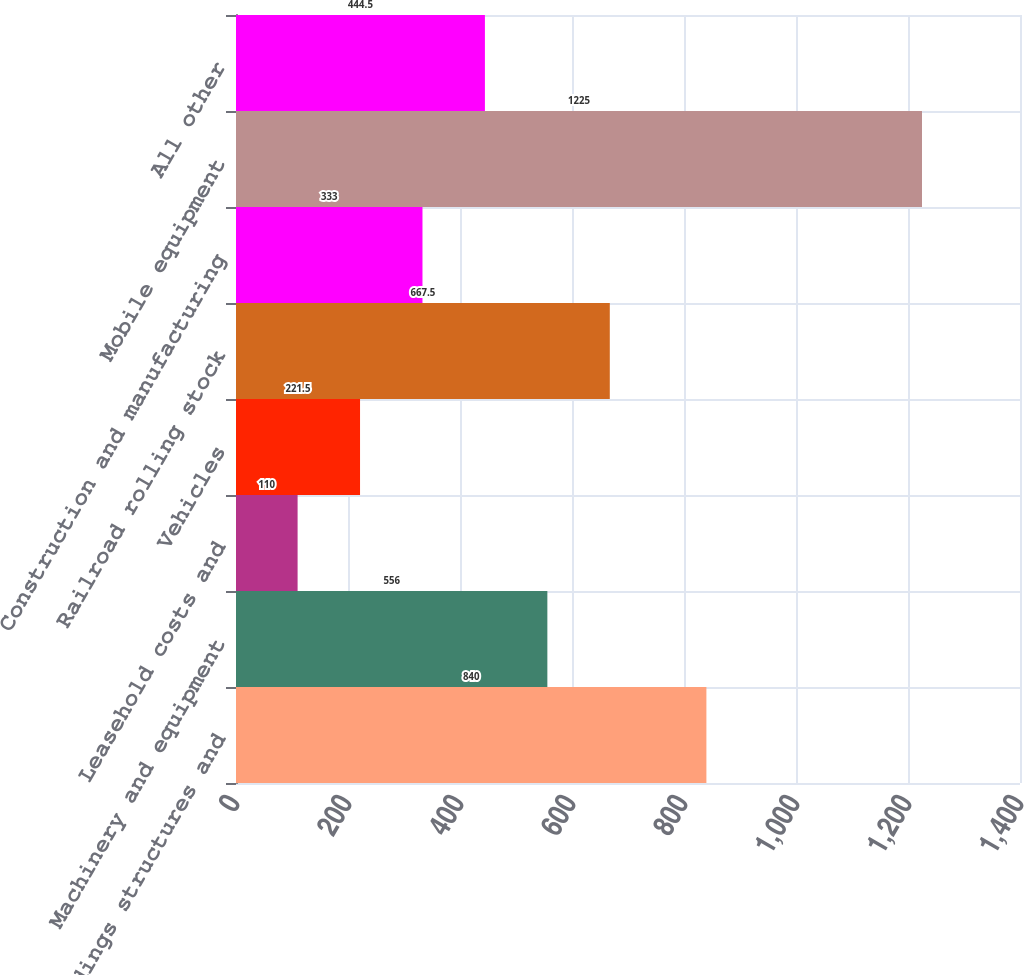Convert chart to OTSL. <chart><loc_0><loc_0><loc_500><loc_500><bar_chart><fcel>Buildings structures and<fcel>Machinery and equipment<fcel>Leasehold costs and<fcel>Vehicles<fcel>Railroad rolling stock<fcel>Construction and manufacturing<fcel>Mobile equipment<fcel>All other<nl><fcel>840<fcel>556<fcel>110<fcel>221.5<fcel>667.5<fcel>333<fcel>1225<fcel>444.5<nl></chart> 